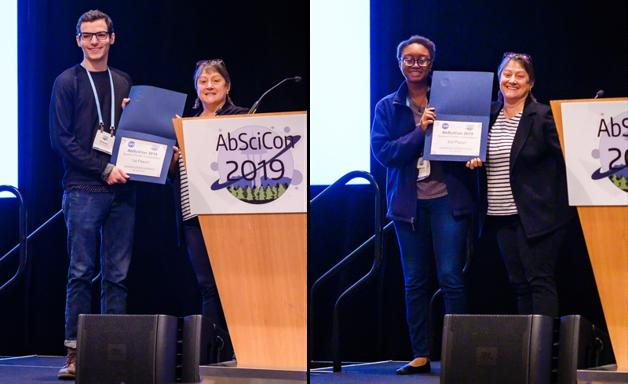Can you tell me more about the type of awards being presented in this image? The awards presented in the image are likely to acknowledge significant contributions to the field of astrobiology, including innovative research, outstanding papers, or notable leadership in fostering interdisciplinary collaborations. 